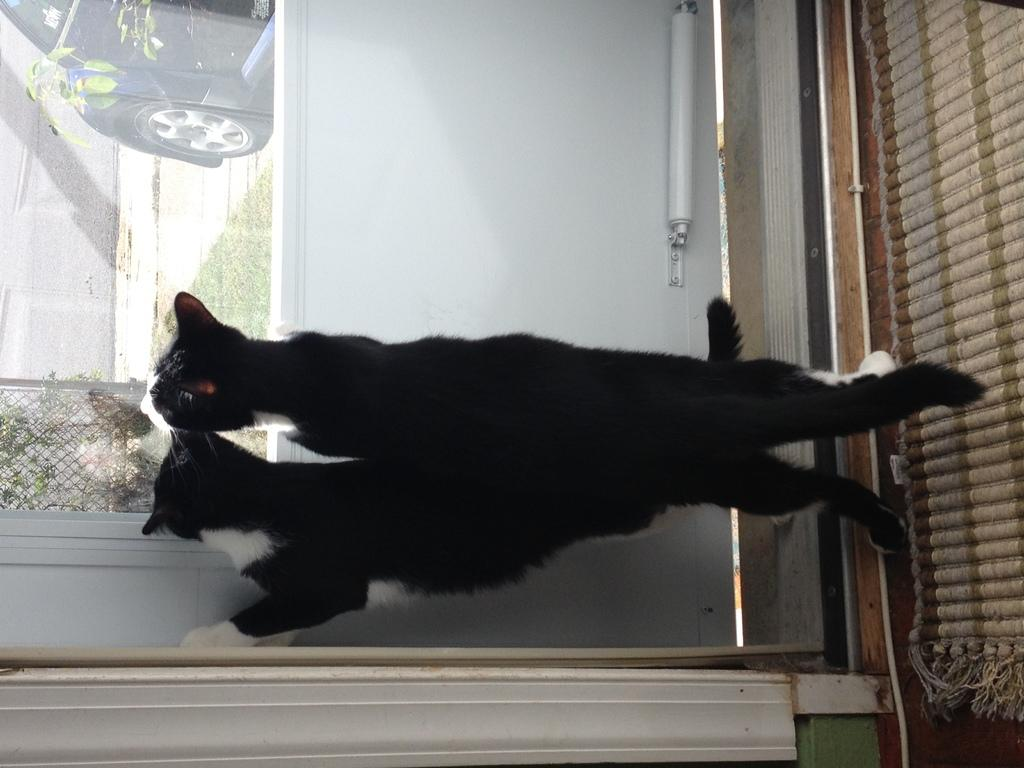What animals can be seen in the foreground of the image? There are two cats in the foreground of the image. What type of barrier is present in the image? There is a fence in the image. What type of surface is visible in the image? There is grass in the image. What is the primary mode of transportation visible in the image? There is a vehicle on the road in the image. What architectural feature is present in the image? There is a wall in the image. Can you describe the setting from which the image may have been taken? The image may have been taken from a room, as there is a glass window visible. What type of frog can be seen in the image? There is no frog present in the image. What financial decisions are being made in the image? The image does not depict any financial decisions or discussions about interest rates. 